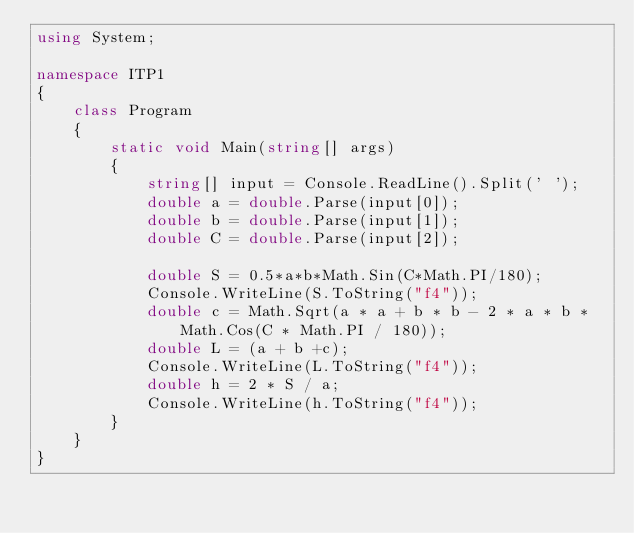<code> <loc_0><loc_0><loc_500><loc_500><_C#_>using System;

namespace ITP1
{
    class Program
    {
        static void Main(string[] args)
        {
            string[] input = Console.ReadLine().Split(' ');
            double a = double.Parse(input[0]);
            double b = double.Parse(input[1]);
            double C = double.Parse(input[2]);
            
            double S = 0.5*a*b*Math.Sin(C*Math.PI/180);
            Console.WriteLine(S.ToString("f4"));
            double c = Math.Sqrt(a * a + b * b - 2 * a * b * Math.Cos(C * Math.PI / 180));
            double L = (a + b +c);
            Console.WriteLine(L.ToString("f4"));
            double h = 2 * S / a;
            Console.WriteLine(h.ToString("f4")); 
        }
    }
}</code> 